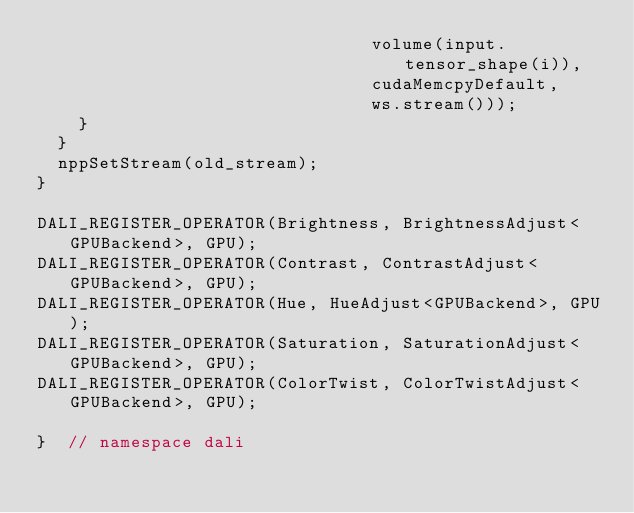<code> <loc_0><loc_0><loc_500><loc_500><_Cuda_>                                volume(input.tensor_shape(i)),
                                cudaMemcpyDefault,
                                ws.stream()));
    }
  }
  nppSetStream(old_stream);
}

DALI_REGISTER_OPERATOR(Brightness, BrightnessAdjust<GPUBackend>, GPU);
DALI_REGISTER_OPERATOR(Contrast, ContrastAdjust<GPUBackend>, GPU);
DALI_REGISTER_OPERATOR(Hue, HueAdjust<GPUBackend>, GPU);
DALI_REGISTER_OPERATOR(Saturation, SaturationAdjust<GPUBackend>, GPU);
DALI_REGISTER_OPERATOR(ColorTwist, ColorTwistAdjust<GPUBackend>, GPU);

}  // namespace dali
</code> 